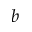Convert formula to latex. <formula><loc_0><loc_0><loc_500><loc_500>b</formula> 